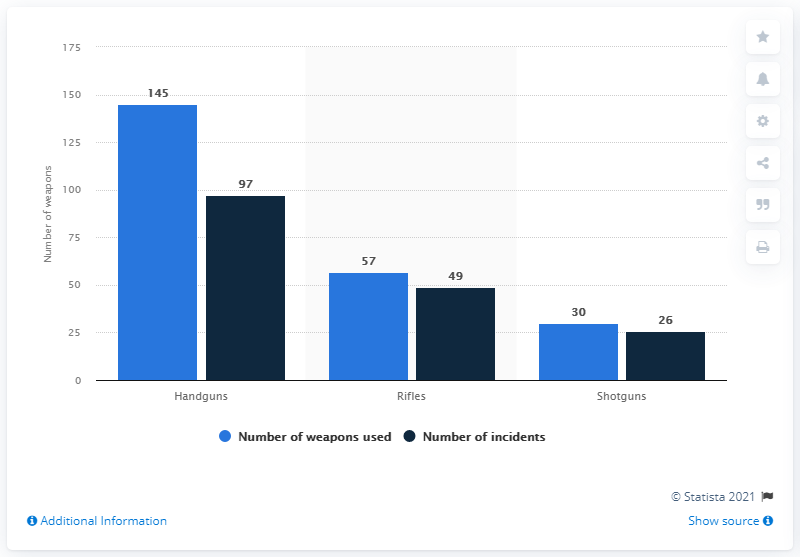List a handful of essential elements in this visual. Handguns are the most commonly used weapon type in mass shootings. There were 97 mass shootings between 1982 and 2021. 